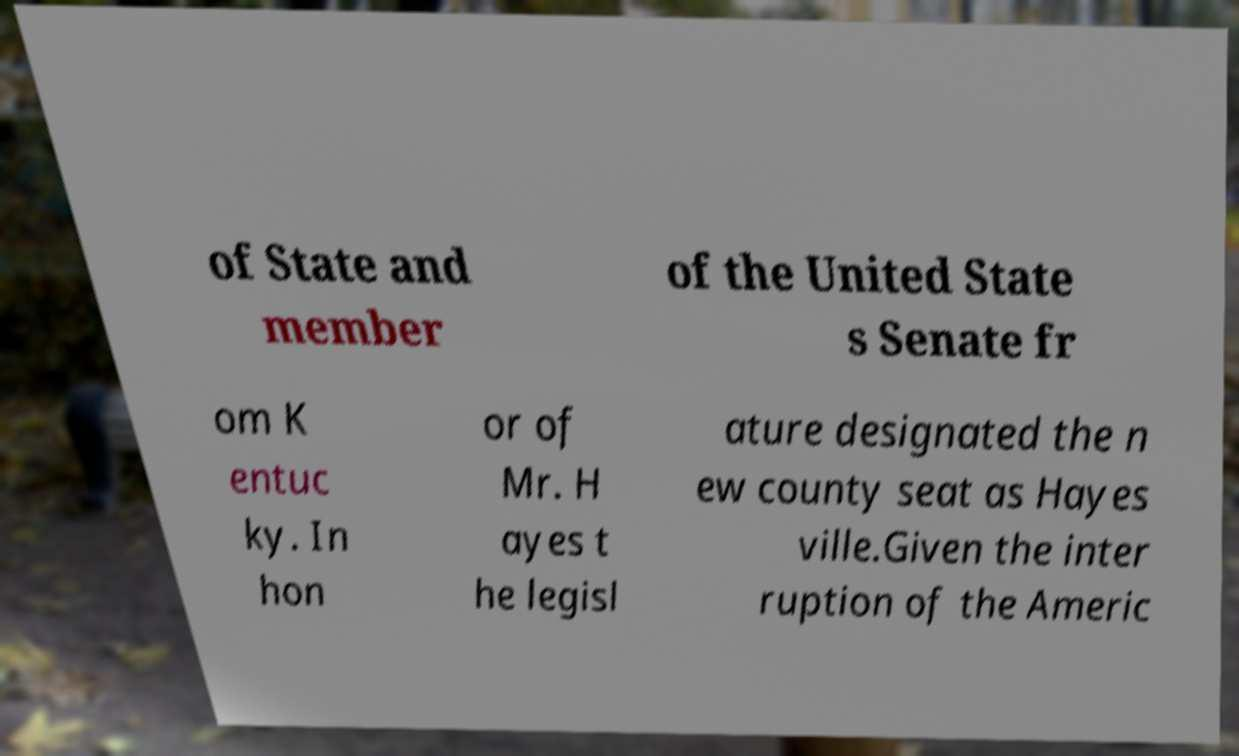Can you accurately transcribe the text from the provided image for me? of State and member of the United State s Senate fr om K entuc ky. In hon or of Mr. H ayes t he legisl ature designated the n ew county seat as Hayes ville.Given the inter ruption of the Americ 